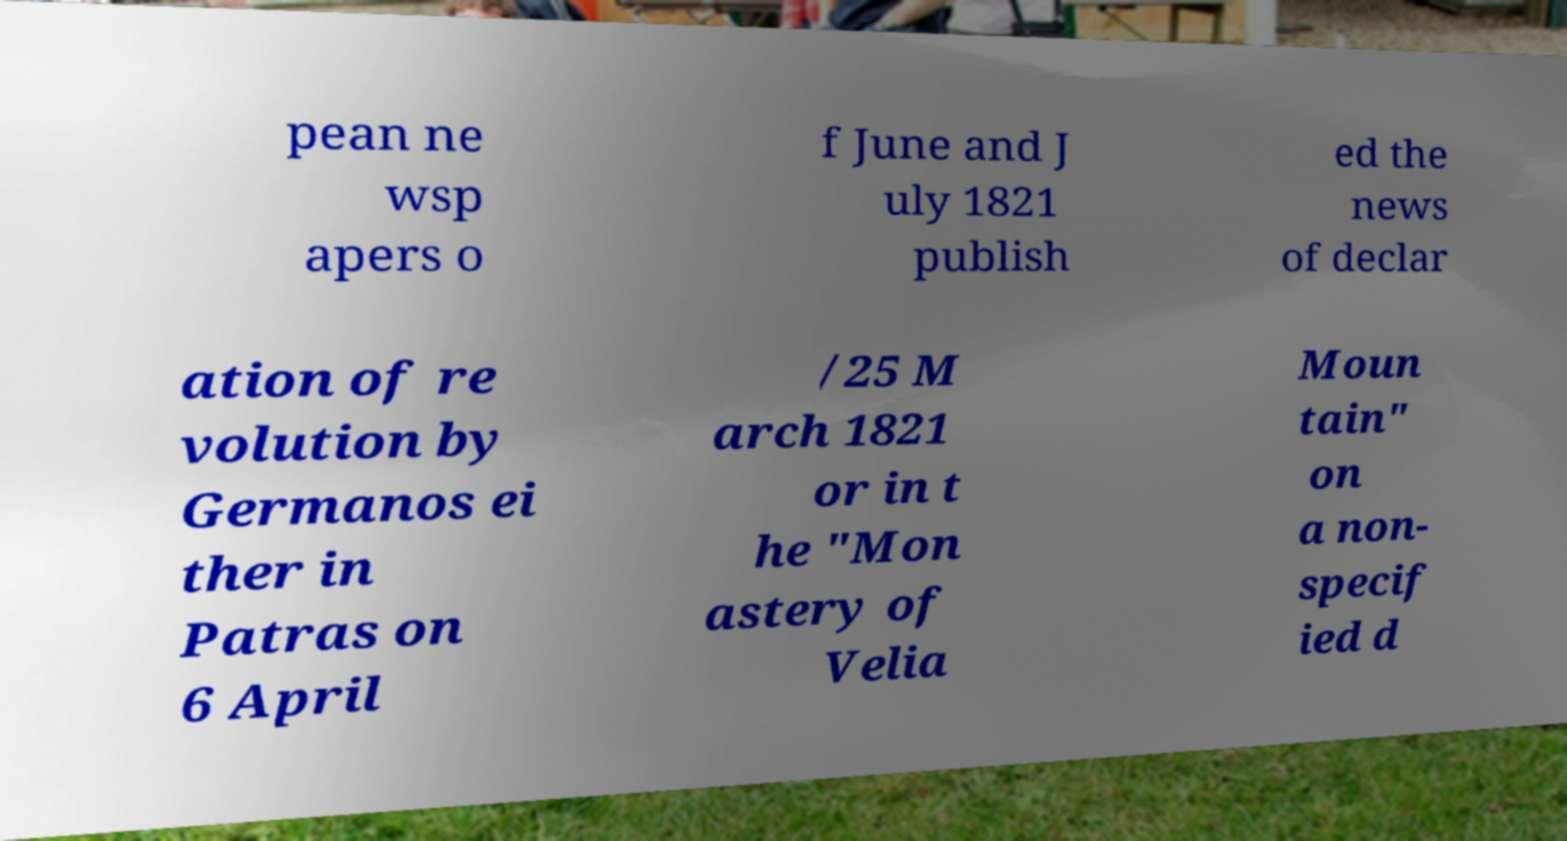Please read and relay the text visible in this image. What does it say? pean ne wsp apers o f June and J uly 1821 publish ed the news of declar ation of re volution by Germanos ei ther in Patras on 6 April /25 M arch 1821 or in t he "Mon astery of Velia Moun tain" on a non- specif ied d 